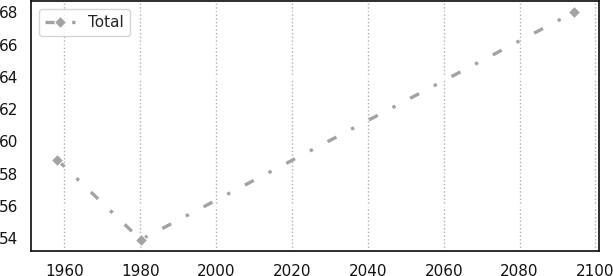<chart> <loc_0><loc_0><loc_500><loc_500><line_chart><ecel><fcel>Total<nl><fcel>1958.1<fcel>58.86<nl><fcel>1980.11<fcel>53.89<nl><fcel>2094.23<fcel>68<nl></chart> 